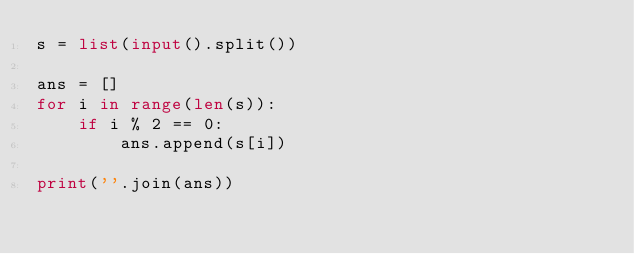Convert code to text. <code><loc_0><loc_0><loc_500><loc_500><_Python_>s = list(input().split())

ans = []
for i in range(len(s)):
    if i % 2 == 0:
        ans.append(s[i])

print(''.join(ans))</code> 